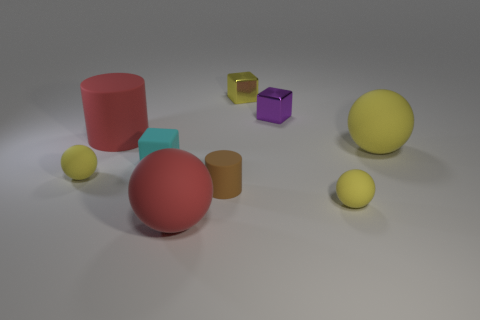How many yellow spheres must be subtracted to get 1 yellow spheres? 2 Subtract all yellow cylinders. How many yellow balls are left? 3 Add 1 tiny cubes. How many objects exist? 10 Subtract all spheres. How many objects are left? 5 Add 4 big yellow spheres. How many big yellow spheres are left? 5 Add 2 large red cylinders. How many large red cylinders exist? 3 Subtract 0 purple cylinders. How many objects are left? 9 Subtract all large yellow shiny cubes. Subtract all tiny purple metallic objects. How many objects are left? 8 